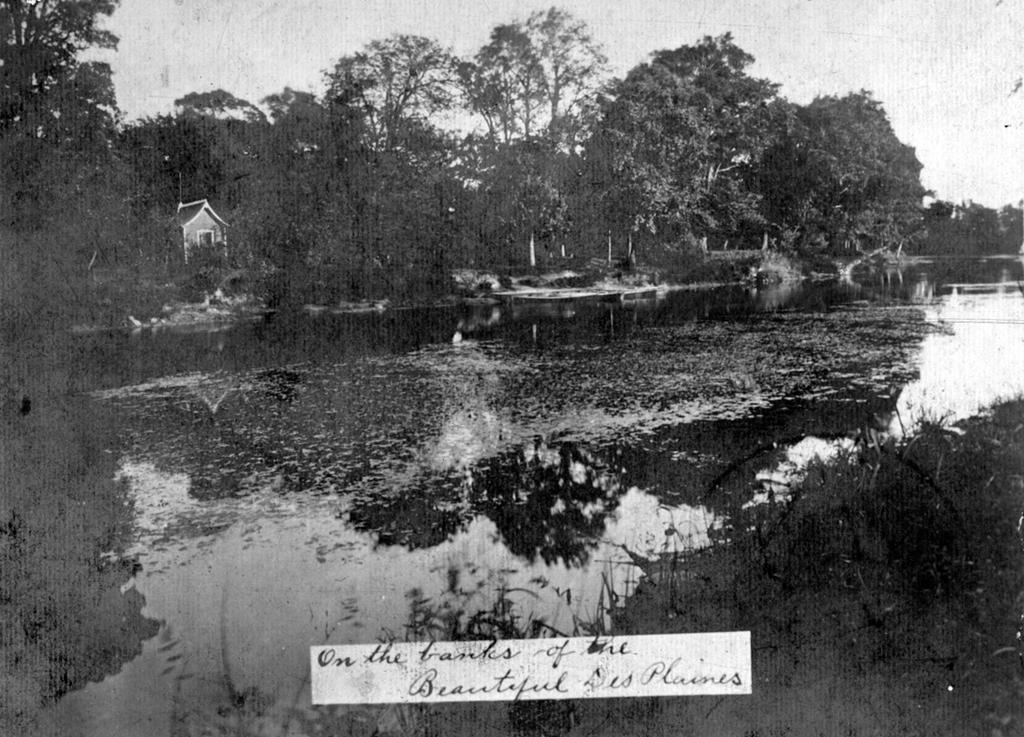Describe this image in one or two sentences. This is a black and white picture. I can see water, there is a house, there are plants, trees, and in the background there is sky and there are letters on the image. 